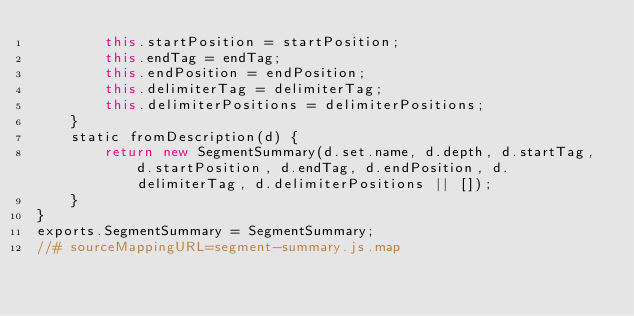Convert code to text. <code><loc_0><loc_0><loc_500><loc_500><_JavaScript_>        this.startPosition = startPosition;
        this.endTag = endTag;
        this.endPosition = endPosition;
        this.delimiterTag = delimiterTag;
        this.delimiterPositions = delimiterPositions;
    }
    static fromDescription(d) {
        return new SegmentSummary(d.set.name, d.depth, d.startTag, d.startPosition, d.endTag, d.endPosition, d.delimiterTag, d.delimiterPositions || []);
    }
}
exports.SegmentSummary = SegmentSummary;
//# sourceMappingURL=segment-summary.js.map</code> 